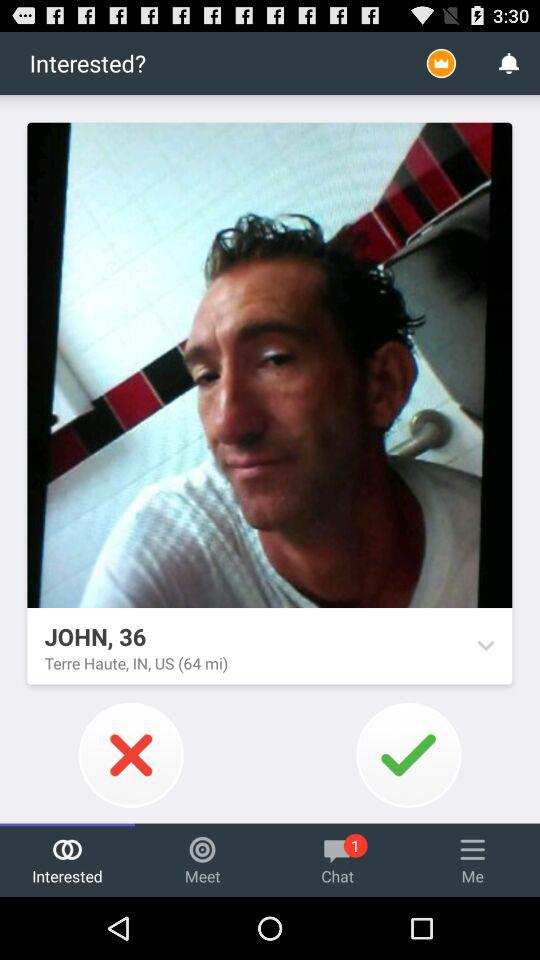How many chats are unread? There is 1 unread chat. 